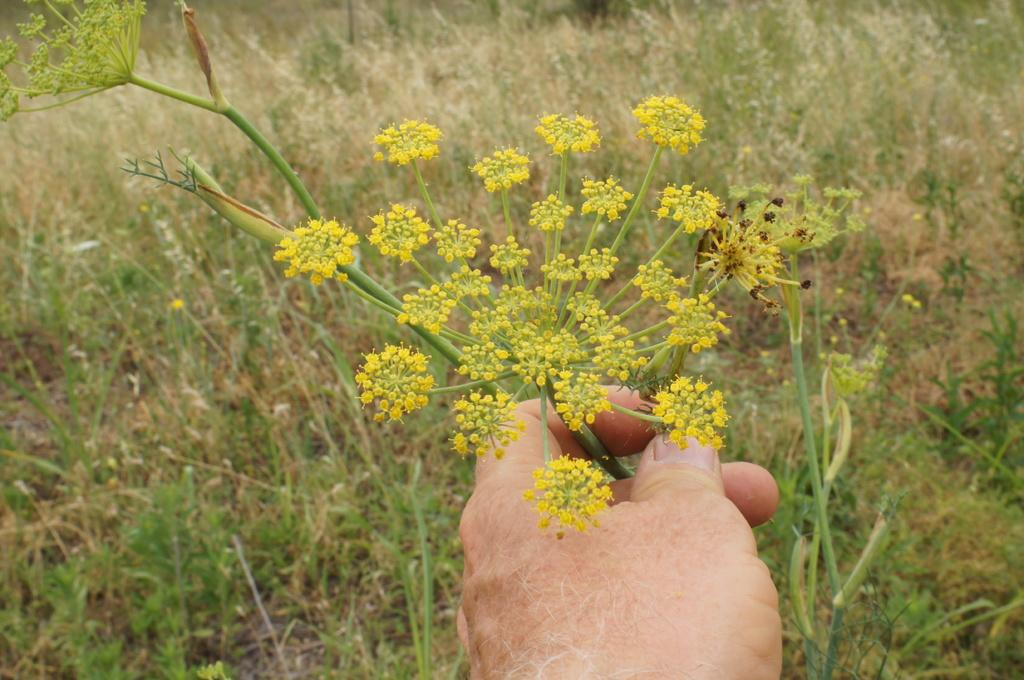What is the person's hand holding in the image? The person's hand is holding flowers in the image. What type of natural environment is visible in the background of the image? There is grass visible in the background of the image. What type of interest can be seen on the person's face in the image? There is no indication of the person's facial expression or interest in the image. What type of marble is visible in the image? There is no marble present in the image. 